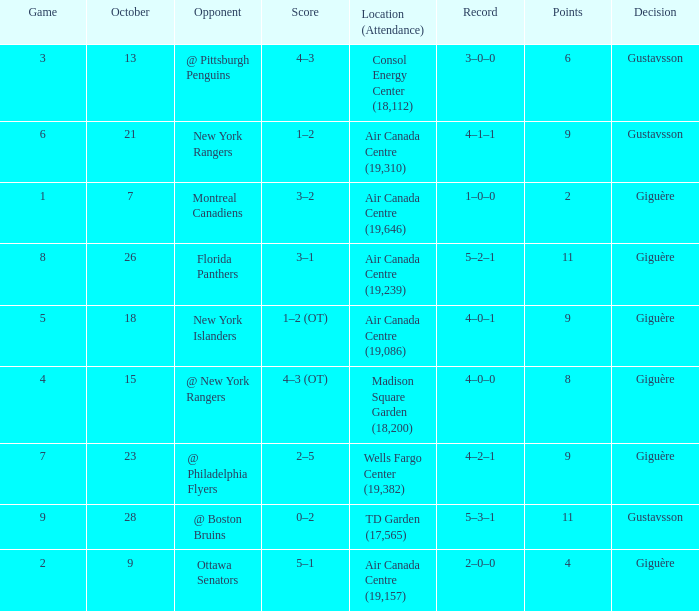What was the score for the opponent florida panthers? 1.0. 